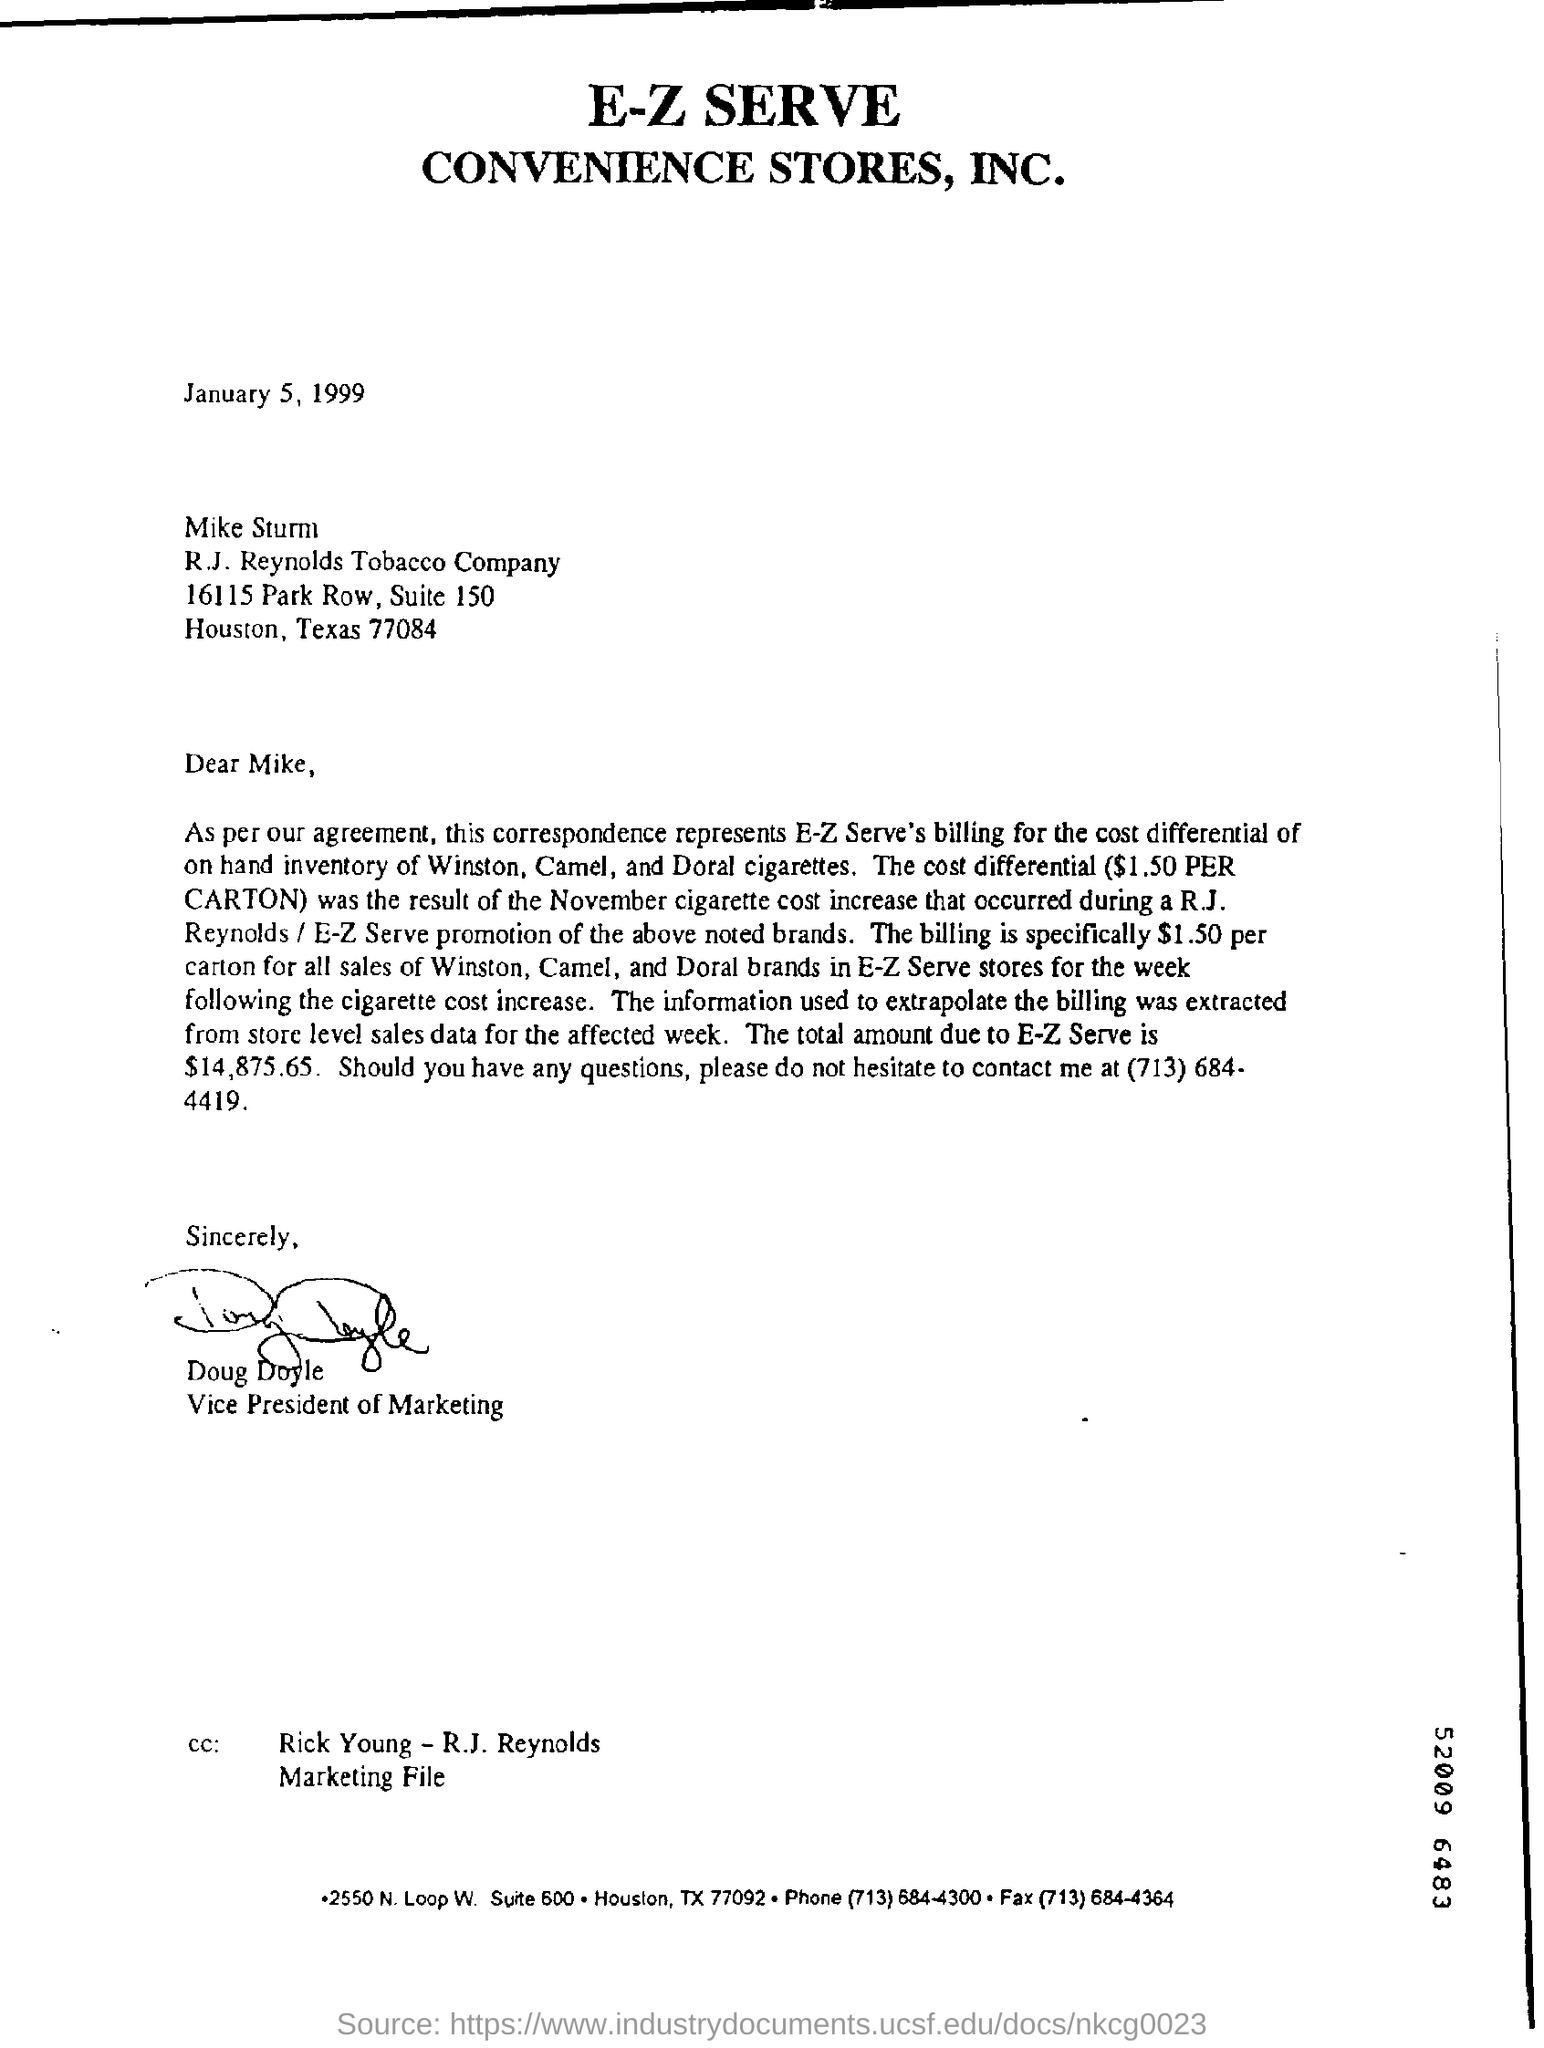Mention a couple of crucial points in this snapshot. This letter is written to Mike Sturm. 